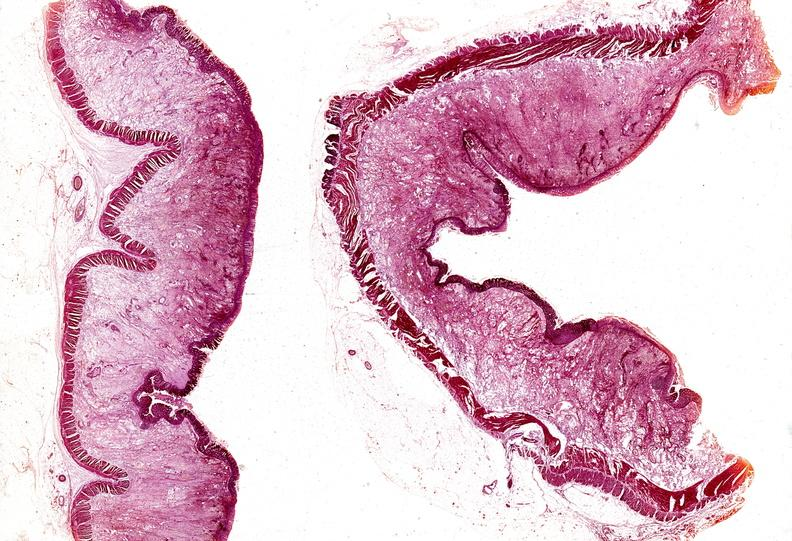does this image show colon, ulcerative colitis?
Answer the question using a single word or phrase. Yes 